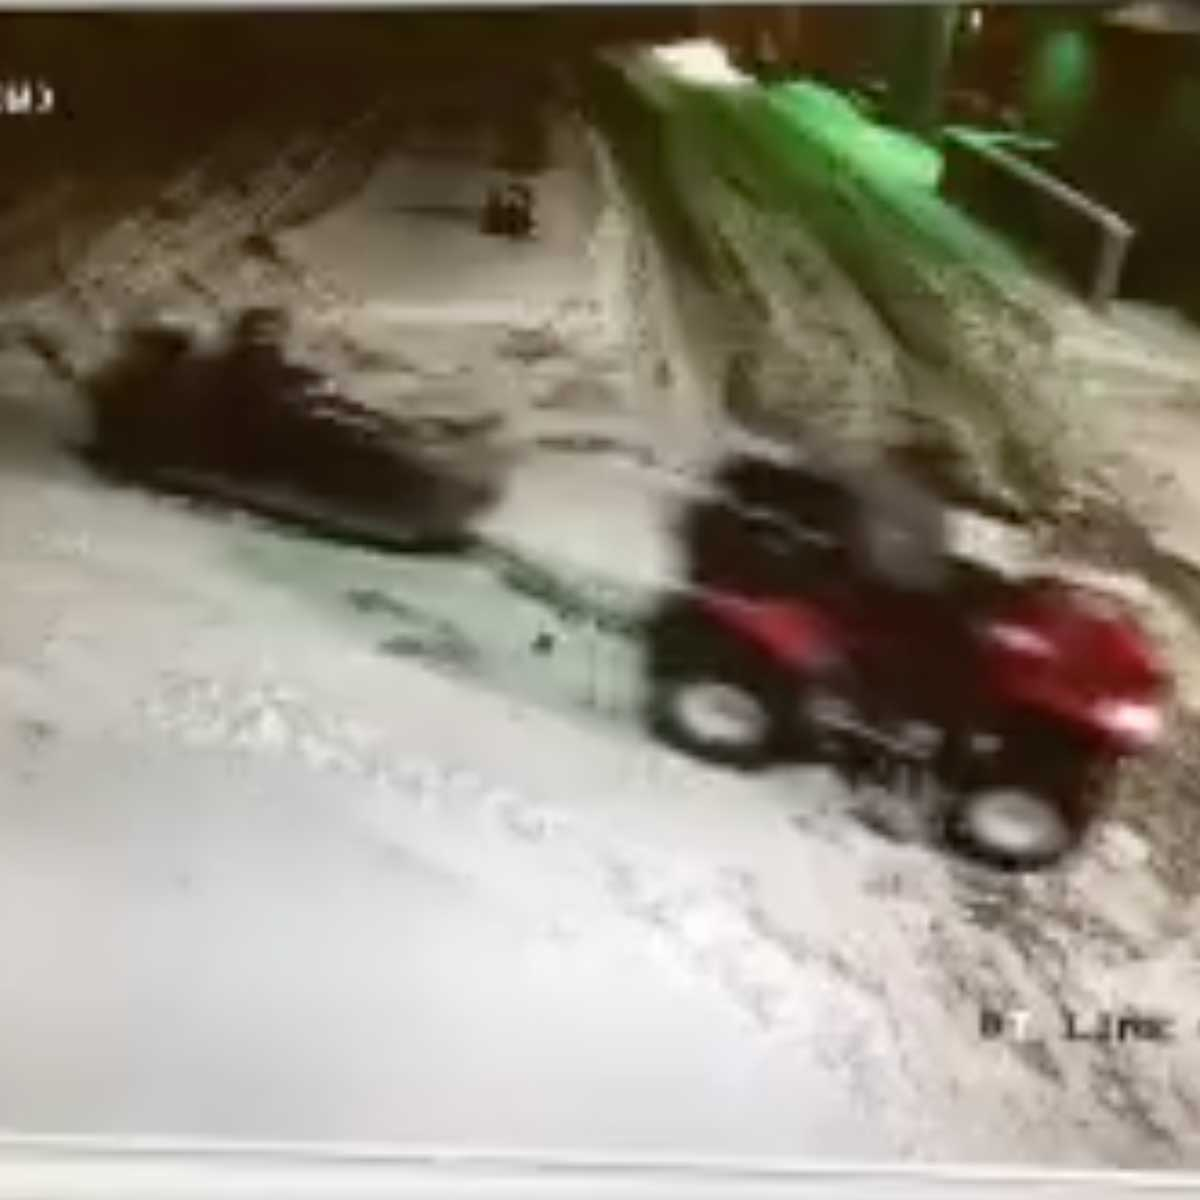Based on the trajectories of the two vehicles or objects, can we infer what might happen next in this scene? Based on the image, it seems that the ATV is moving towards the smaller, darker object. If both continue on their current paths without any changes, it is likely that the trajectories of the ATV and the smaller object will intersect. This could result in one of several outcomes: the ATV might adjust its path to avoid the object, or it might come into contact with it. The exact outcome is uncertain without more frames or motion data, but the possibility of an intersection is significant. 